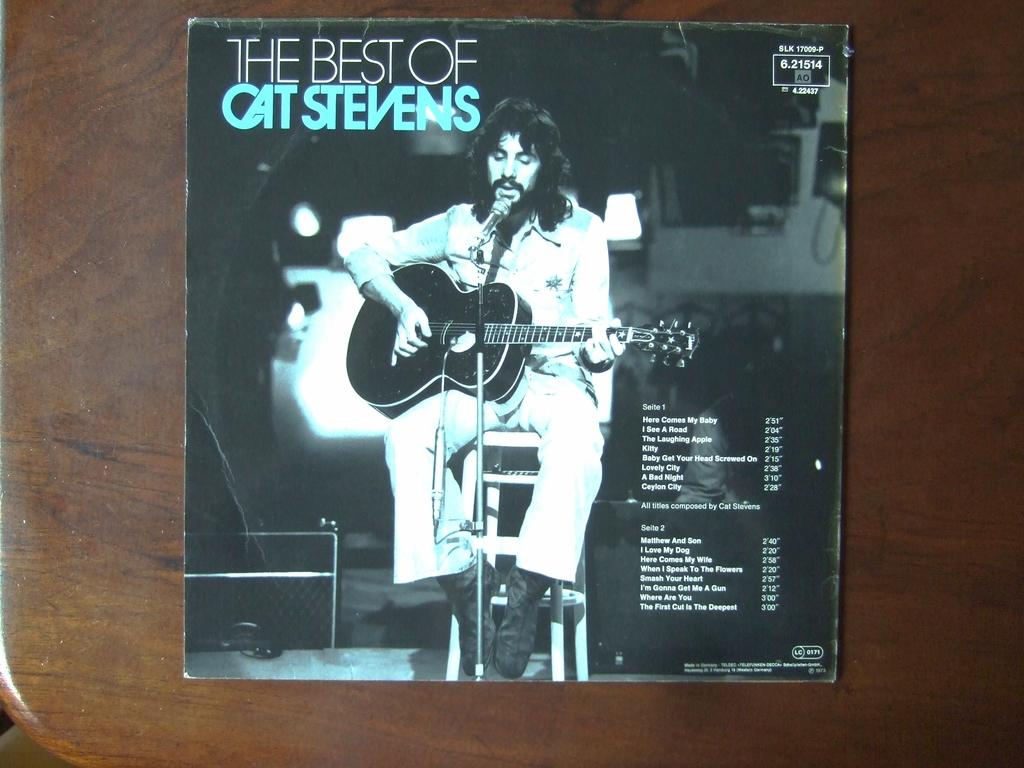What is depicted on the poster in the image? The poster features a person holding a guitar. What else can be seen on the poster besides the person with the guitar? There is text written on the poster. What is visible in the background of the image? There is a table in the background of the image. Can you hear the sound of bells ringing in the image? There is no auditory information provided in the image, so it is not possible to determine if bells are ringing or not. 